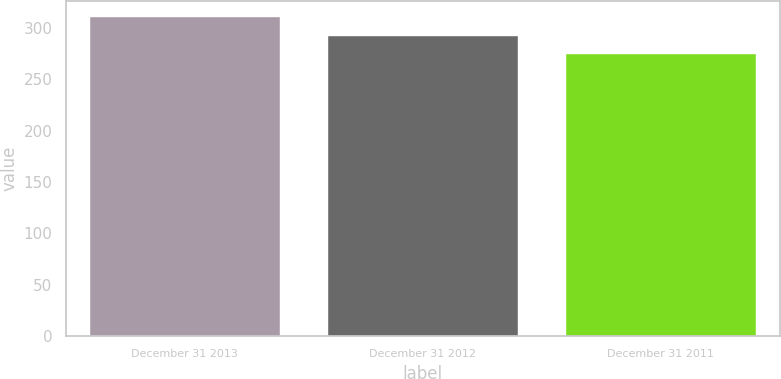Convert chart. <chart><loc_0><loc_0><loc_500><loc_500><bar_chart><fcel>December 31 2013<fcel>December 31 2012<fcel>December 31 2011<nl><fcel>310.5<fcel>292.6<fcel>274.6<nl></chart> 